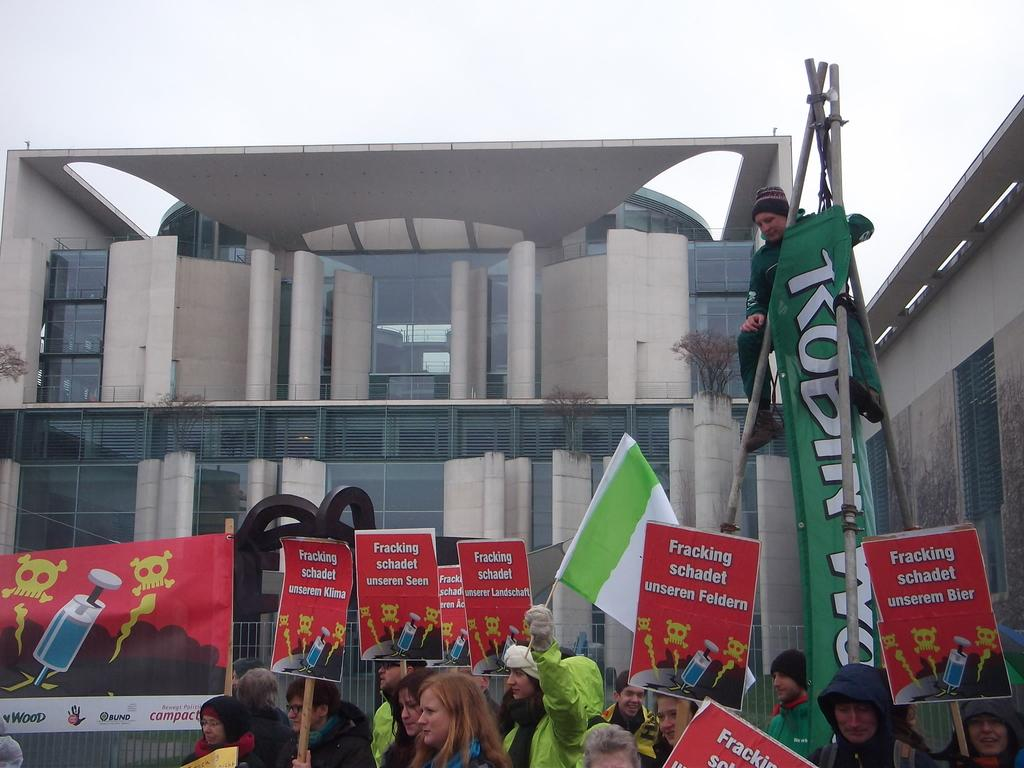How many people are in the image? There is a group of people in the image. What type of decorations can be seen in the image? There are posters, banners, and a flag in the image. What structures are present in the image? There are poles, a sculpture, a fence, and buildings in the image. What type of vegetation is visible in the image? There are plants in the image. What can be seen in the background of the image? The sky is visible in the background of the image. What type of lace is draped over the sculpture in the image? There is no lace present in the image; it only features a sculpture, among other objects and structures. Can you tell me what your dad is doing in the image? There is no specific person mentioned in the image, so it is impossible to determine what your dad is doing. 